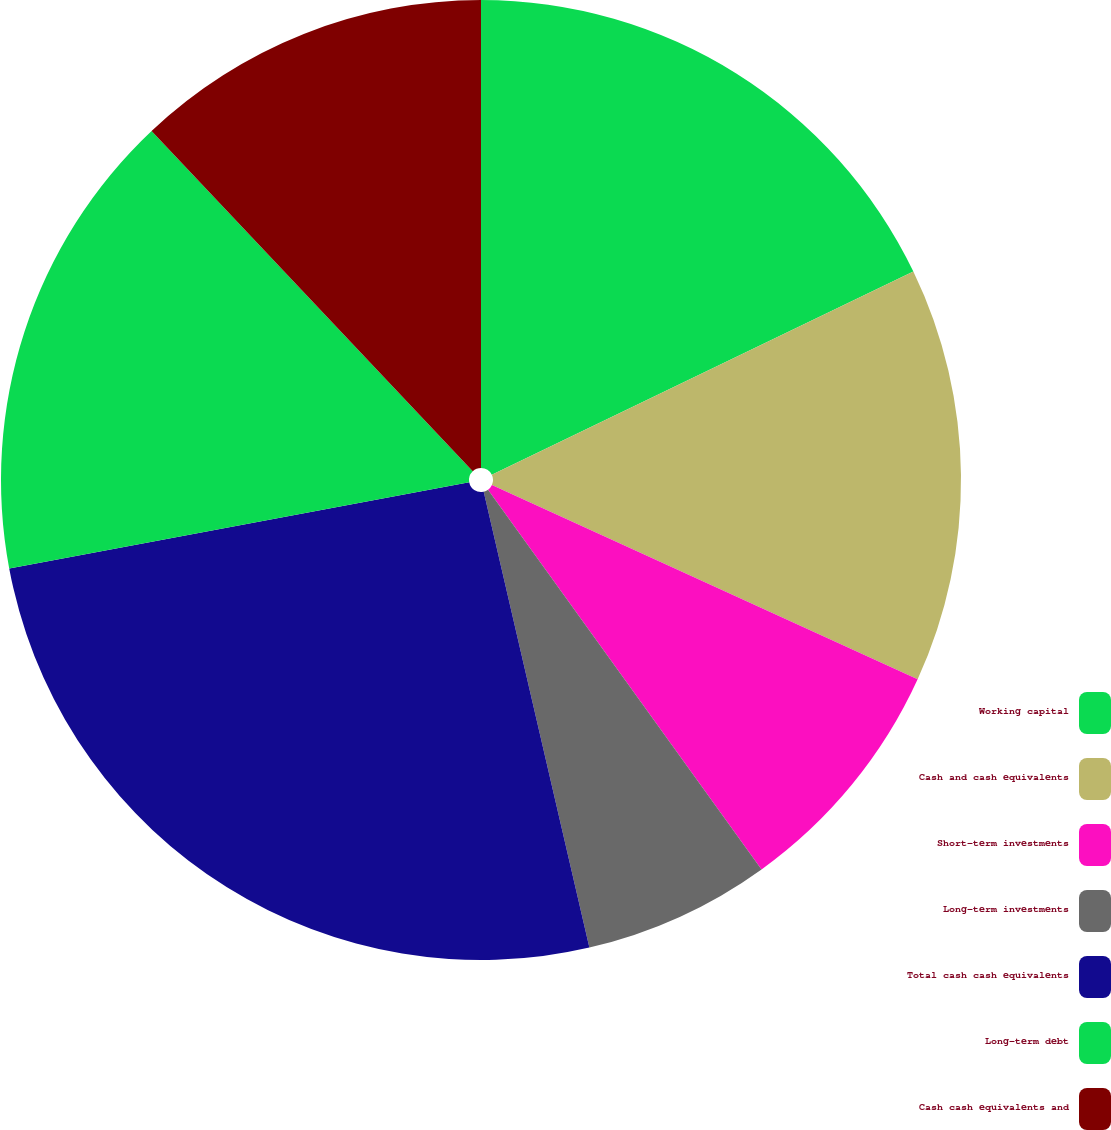<chart> <loc_0><loc_0><loc_500><loc_500><pie_chart><fcel>Working capital<fcel>Cash and cash equivalents<fcel>Short-term investments<fcel>Long-term investments<fcel>Total cash cash equivalents<fcel>Long-term debt<fcel>Cash cash equivalents and<nl><fcel>17.85%<fcel>13.97%<fcel>8.25%<fcel>6.31%<fcel>25.68%<fcel>15.91%<fcel>12.04%<nl></chart> 